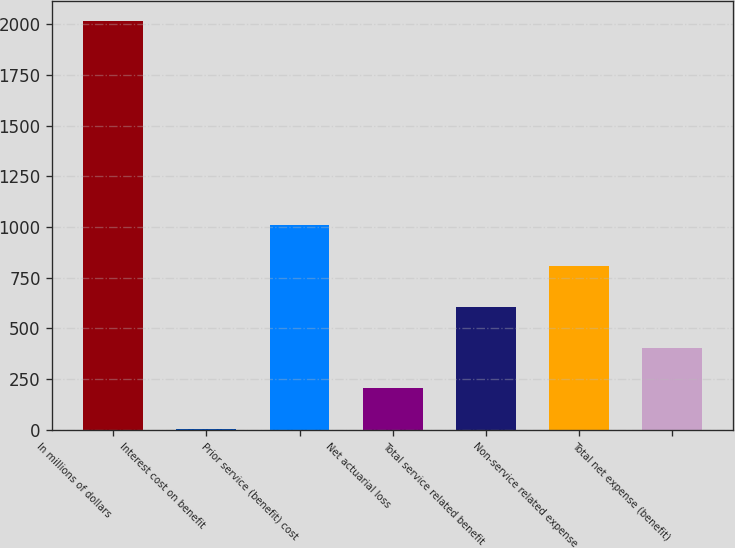Convert chart to OTSL. <chart><loc_0><loc_0><loc_500><loc_500><bar_chart><fcel>In millions of dollars<fcel>Interest cost on benefit<fcel>Prior service (benefit) cost<fcel>Net actuarial loss<fcel>Total service related benefit<fcel>Non-service related expense<fcel>Total net expense (benefit)<nl><fcel>2017<fcel>2<fcel>1009.5<fcel>203.5<fcel>606.5<fcel>808<fcel>405<nl></chart> 